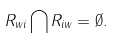<formula> <loc_0><loc_0><loc_500><loc_500>R _ { w i } \bigcap R _ { i w } = \emptyset .</formula> 